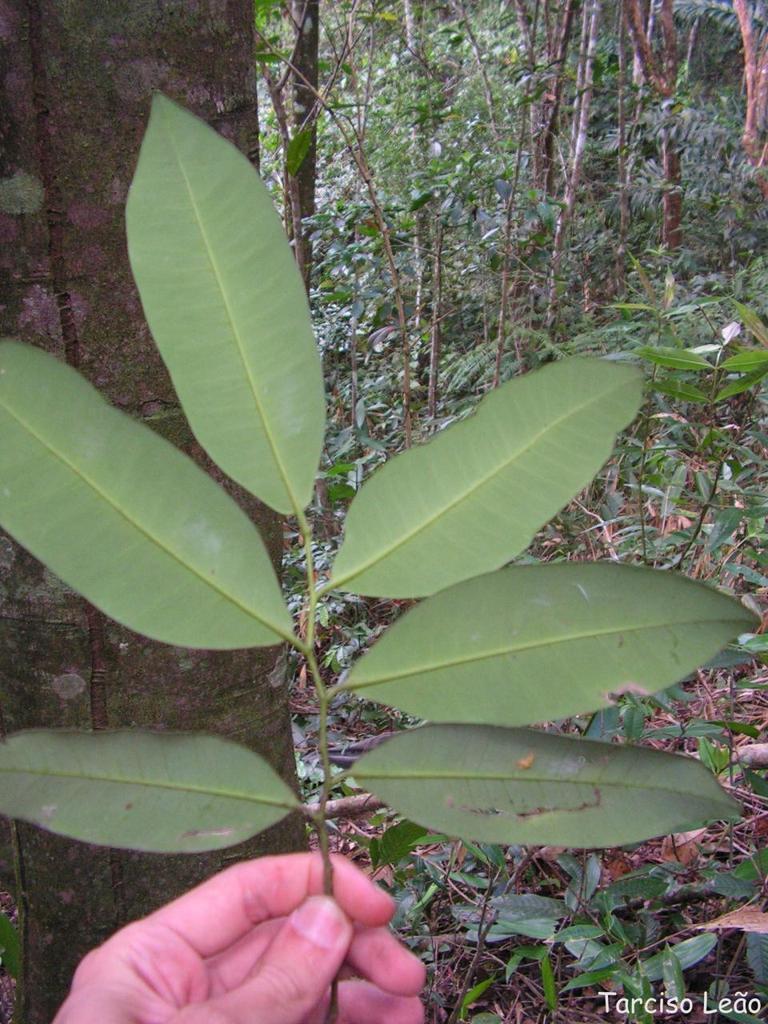Could you give a brief overview of what you see in this image? A human is holding the leaves, there are trees in this image. 